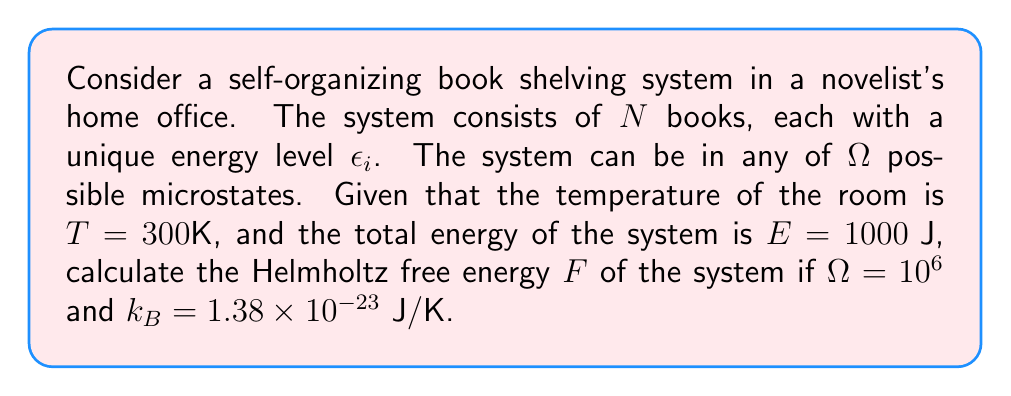What is the answer to this math problem? To calculate the Helmholtz free energy, we'll use the formula:

$$F = E - TS$$

Where:
$F$ is the Helmholtz free energy
$E$ is the total energy of the system
$T$ is the temperature
$S$ is the entropy

Step 1: We already know $E$ and $T$. We need to calculate $S$.

Step 2: For a system with $\Omega$ microstates, the entropy is given by Boltzmann's formula:

$$S = k_B \ln \Omega$$

Step 3: Calculate the entropy:
$$S = (1.38 \times 10^{-23} \text{ J/K}) \times \ln(10^6)$$
$$S = (1.38 \times 10^{-23} \text{ J/K}) \times (6 \ln 10)$$
$$S = 1.91 \times 10^{-22} \text{ J/K}$$

Step 4: Now we can calculate the Helmholtz free energy:
$$F = E - TS$$
$$F = 1000 \text{ J} - (300 \text{ K}) \times (1.91 \times 10^{-22} \text{ J/K})$$
$$F = 1000 \text{ J} - 5.73 \times 10^{-20} \text{ J}$$
$$F \approx 1000 \text{ J}$$

The change due to the $TS$ term is negligible compared to the total energy $E$.
Answer: $F \approx 1000 \text{ J}$ 